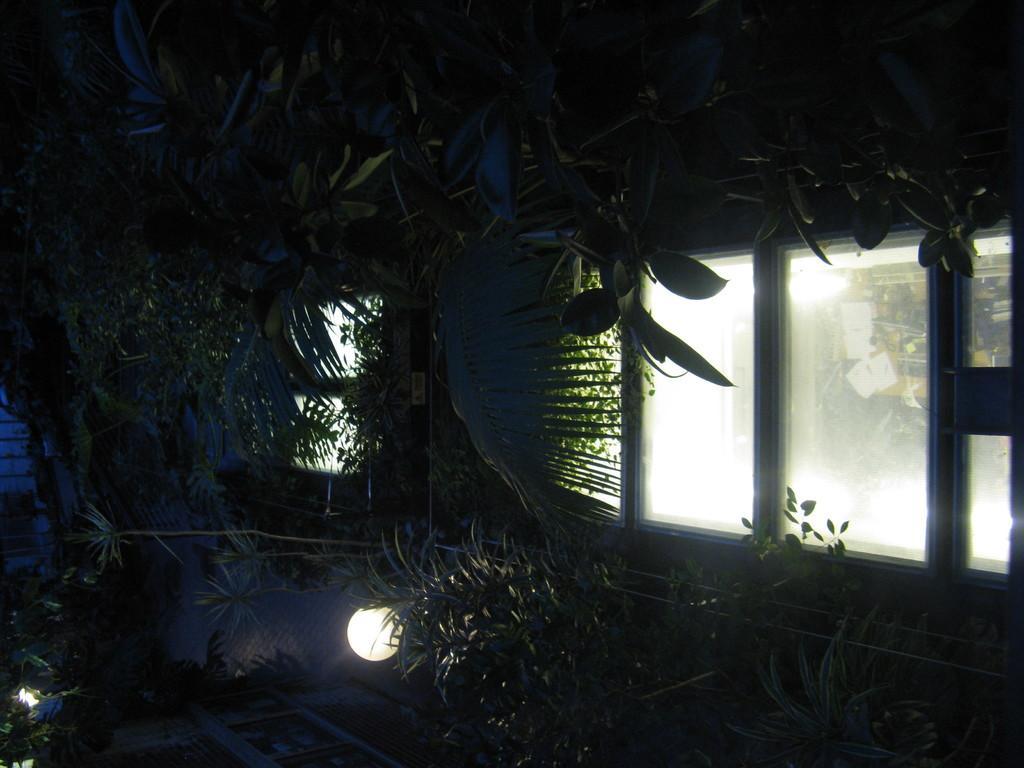In one or two sentences, can you explain what this image depicts? In this picture we can see the trees, plants and grass. At the bottom there is a light. On the right we can see many windows. Through the window we can see the door and wall. 